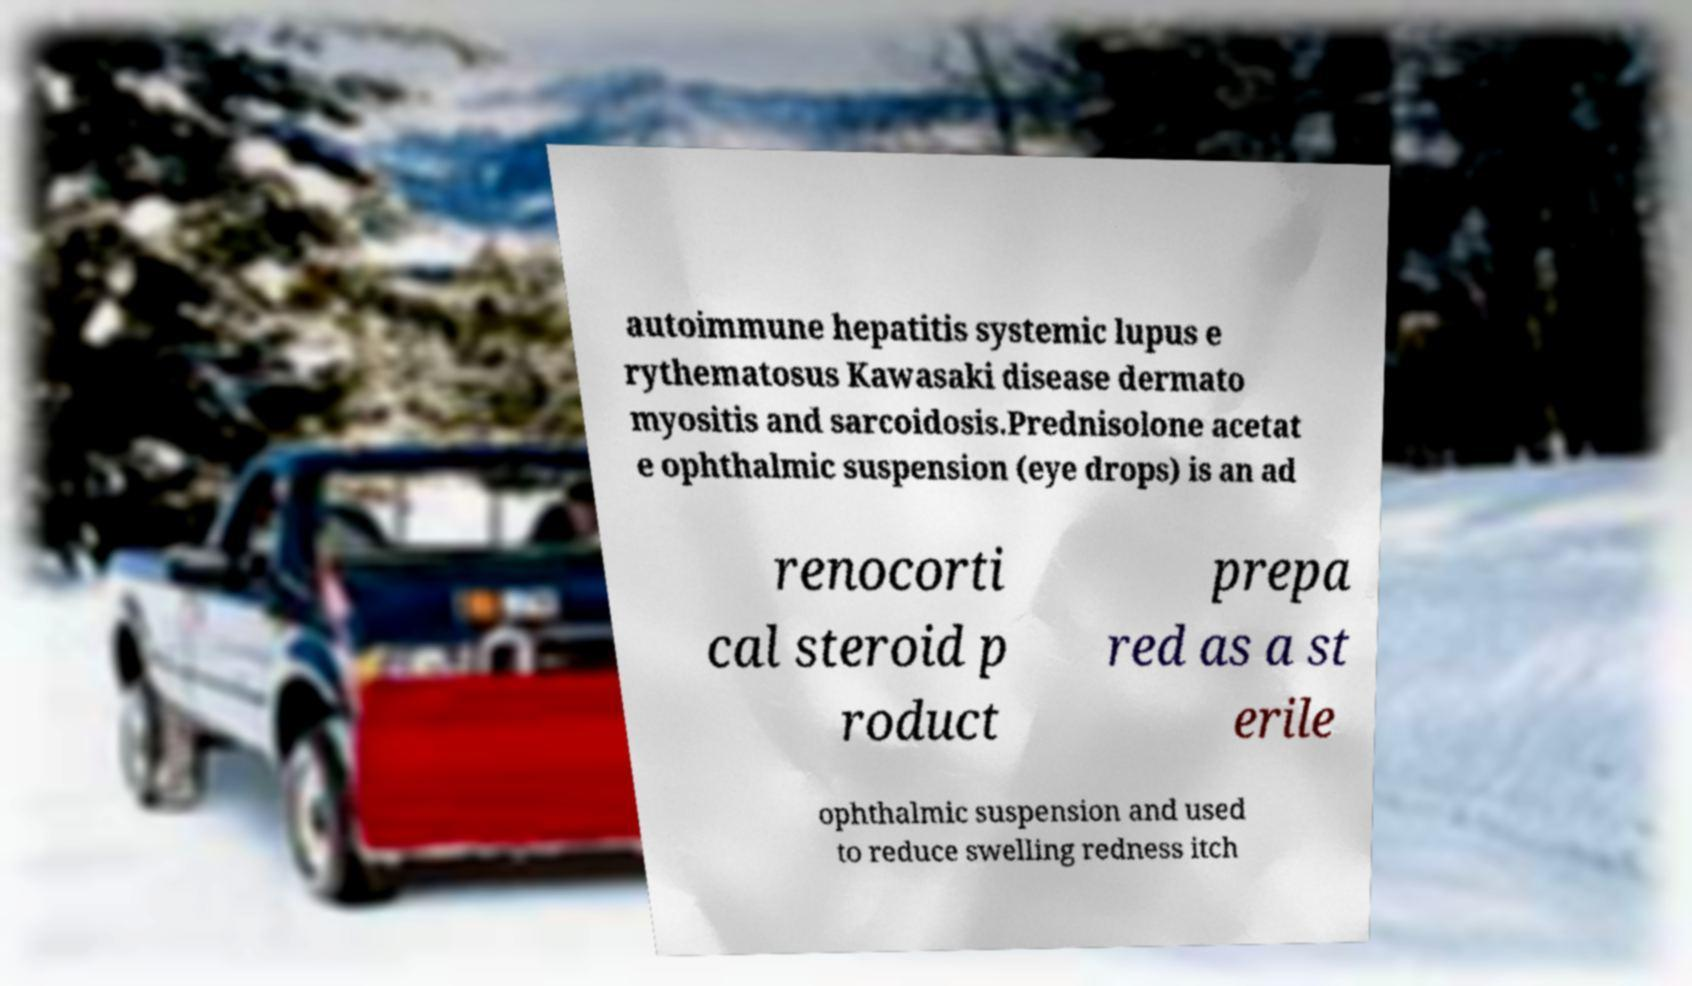What messages or text are displayed in this image? I need them in a readable, typed format. autoimmune hepatitis systemic lupus e rythematosus Kawasaki disease dermato myositis and sarcoidosis.Prednisolone acetat e ophthalmic suspension (eye drops) is an ad renocorti cal steroid p roduct prepa red as a st erile ophthalmic suspension and used to reduce swelling redness itch 